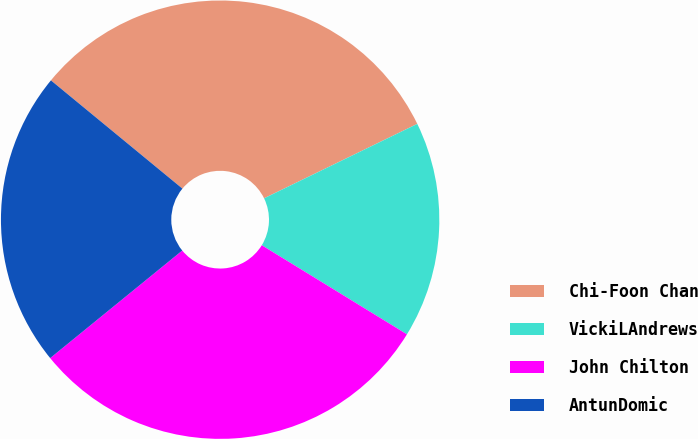<chart> <loc_0><loc_0><loc_500><loc_500><pie_chart><fcel>Chi-Foon Chan<fcel>VickiLAndrews<fcel>John Chilton<fcel>AntunDomic<nl><fcel>31.84%<fcel>15.96%<fcel>30.36%<fcel>21.84%<nl></chart> 